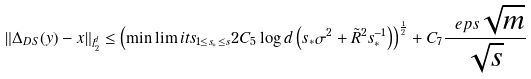<formula> <loc_0><loc_0><loc_500><loc_500>\| \Delta _ { D S } ( y ) - x \| _ { l _ { 2 } ^ { d } } \leq \left ( \min \lim i t s _ { 1 \leq s _ { * } \leq s } 2 C _ { 5 } \log d \left ( s _ { * } \sigma ^ { 2 } + \tilde { R } ^ { 2 } s _ { * } ^ { - 1 } \right ) \right ) ^ { \frac { 1 } { 2 } } + C _ { 7 } \frac { \ e p s \sqrt { m } } { \sqrt { s } }</formula> 